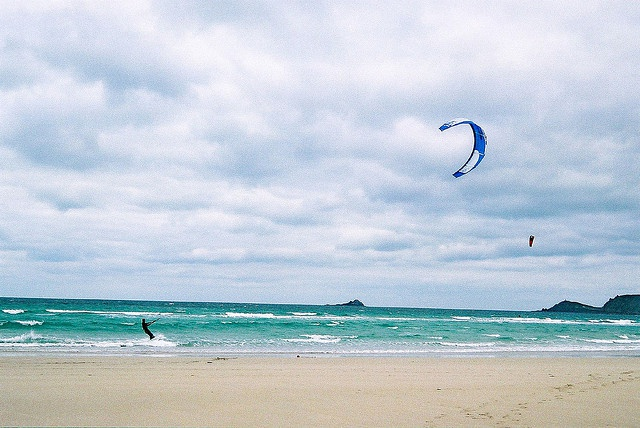Describe the objects in this image and their specific colors. I can see kite in lavender, lightgray, blue, and navy tones, people in lavender, black, teal, and gray tones, kite in lavender, black, maroon, gray, and darkgray tones, and surfboard in lavender, lightgray, and darkgray tones in this image. 